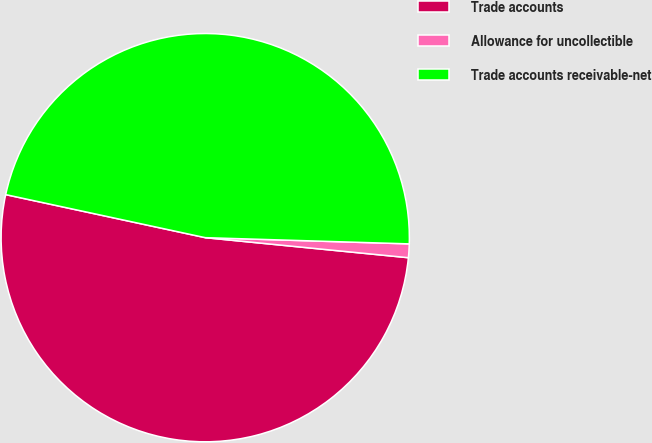<chart> <loc_0><loc_0><loc_500><loc_500><pie_chart><fcel>Trade accounts<fcel>Allowance for uncollectible<fcel>Trade accounts receivable-net<nl><fcel>51.81%<fcel>1.08%<fcel>47.1%<nl></chart> 